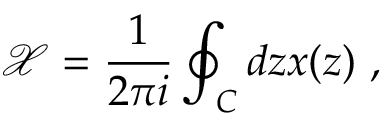<formula> <loc_0><loc_0><loc_500><loc_500>\mathcal { X } = \frac { 1 } { 2 \pi i } \oint _ { C } d z x ( z ) \ ,</formula> 